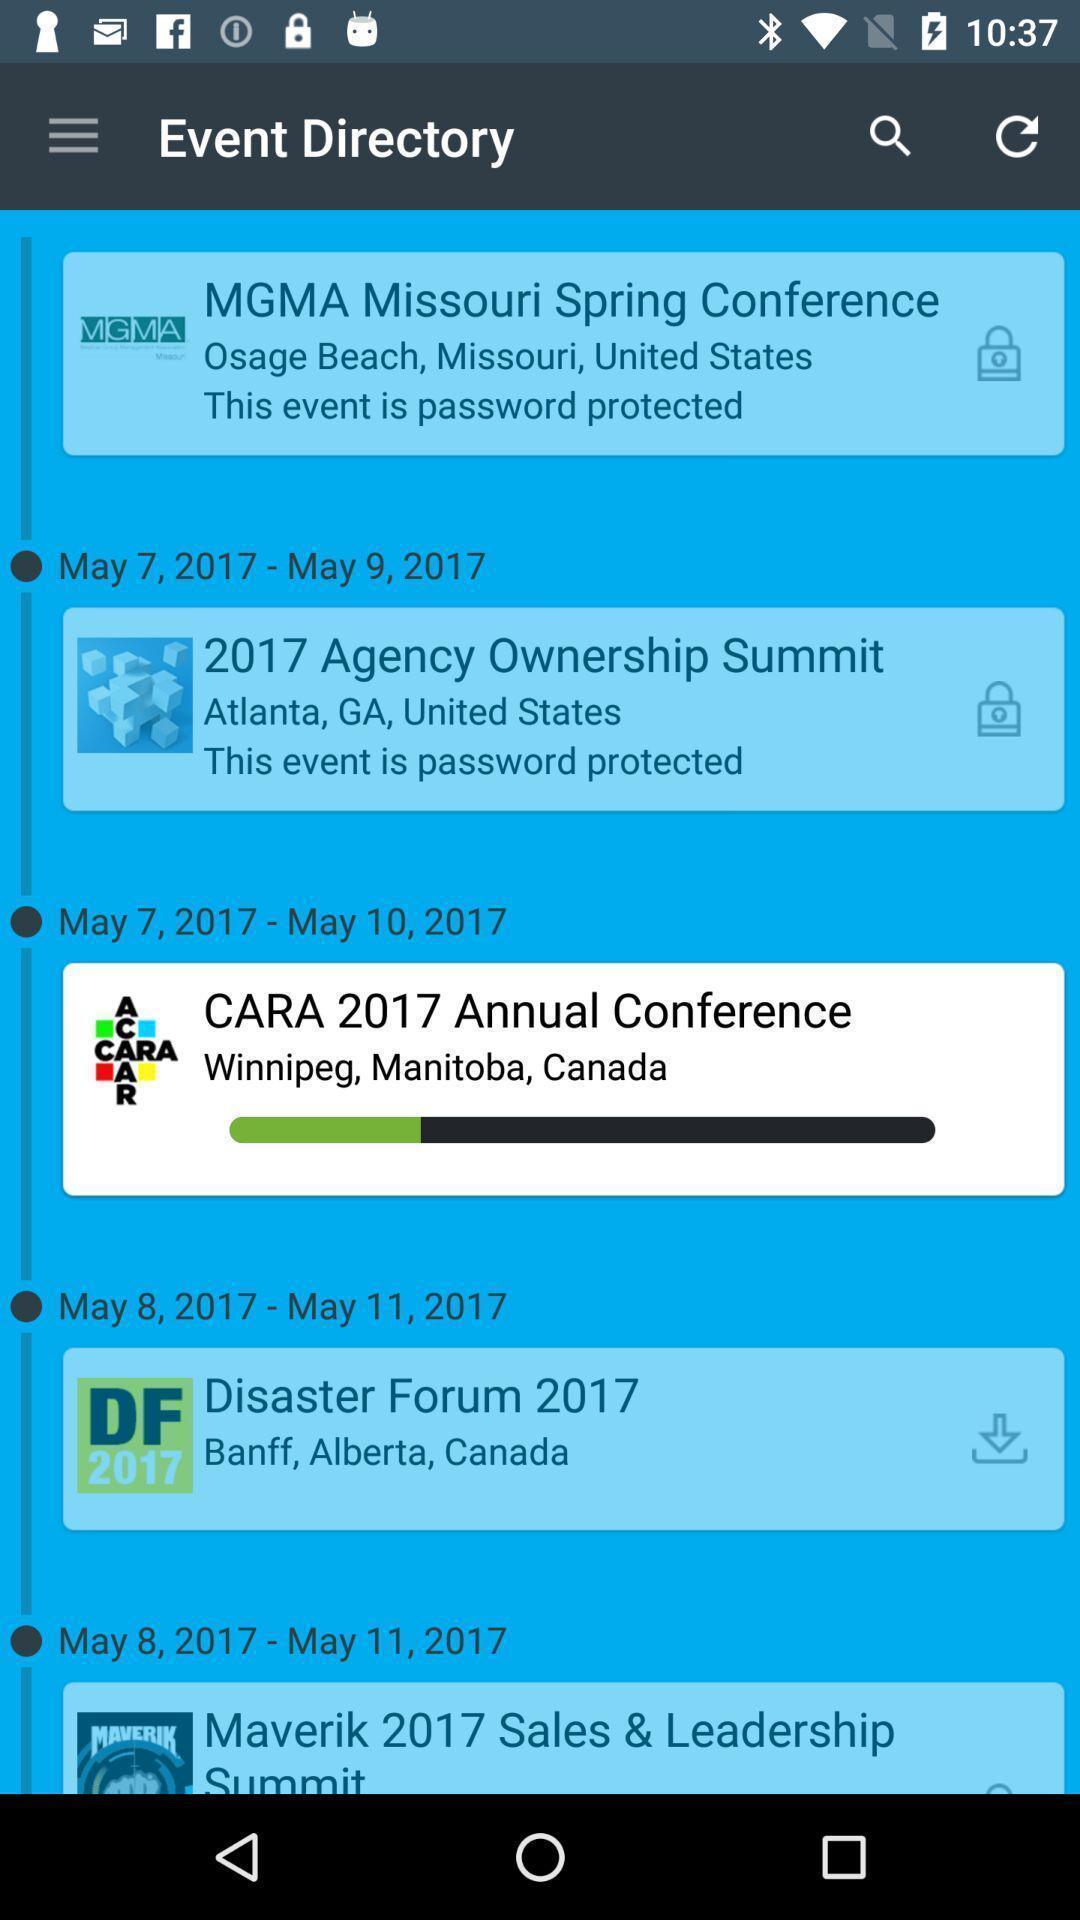Explain the elements present in this screenshot. Screen displaying multiple events information with date and location. 